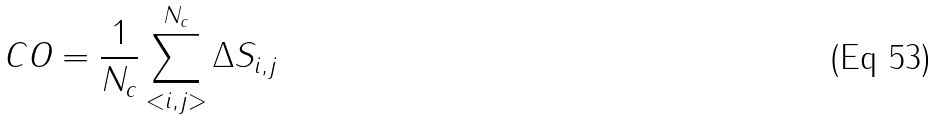Convert formula to latex. <formula><loc_0><loc_0><loc_500><loc_500>C O = \frac { 1 } { N _ { c } } \sum ^ { N _ { c } } _ { < i , j > } \Delta S _ { i , j }</formula> 